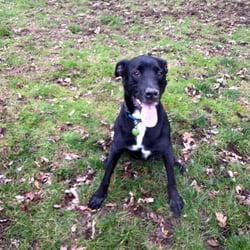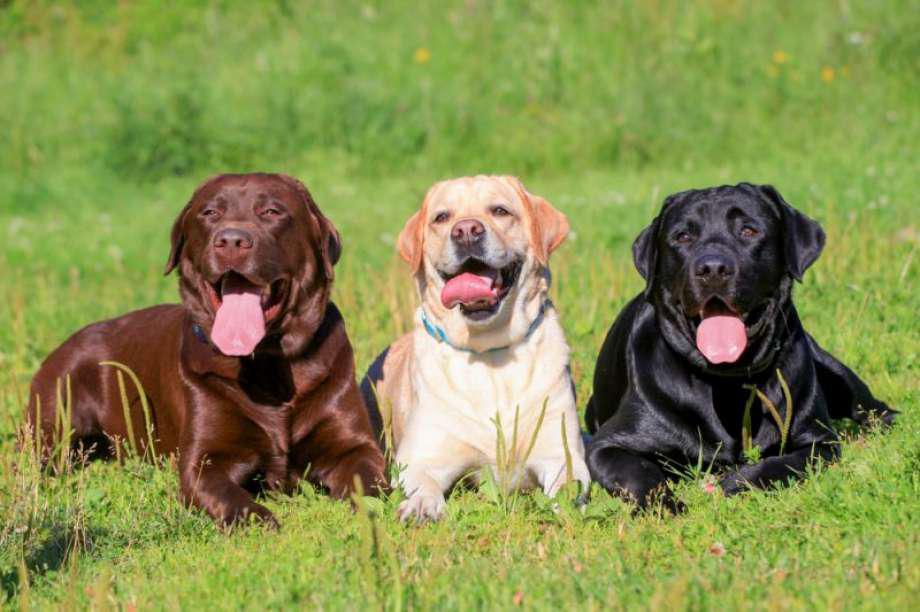The first image is the image on the left, the second image is the image on the right. Examine the images to the left and right. Is the description "The dog in one of the images is wearing a red collar around its neck." accurate? Answer yes or no. No. The first image is the image on the left, the second image is the image on the right. Assess this claim about the two images: "There is at least one dog whose mouth is completely closed.". Correct or not? Answer yes or no. No. 